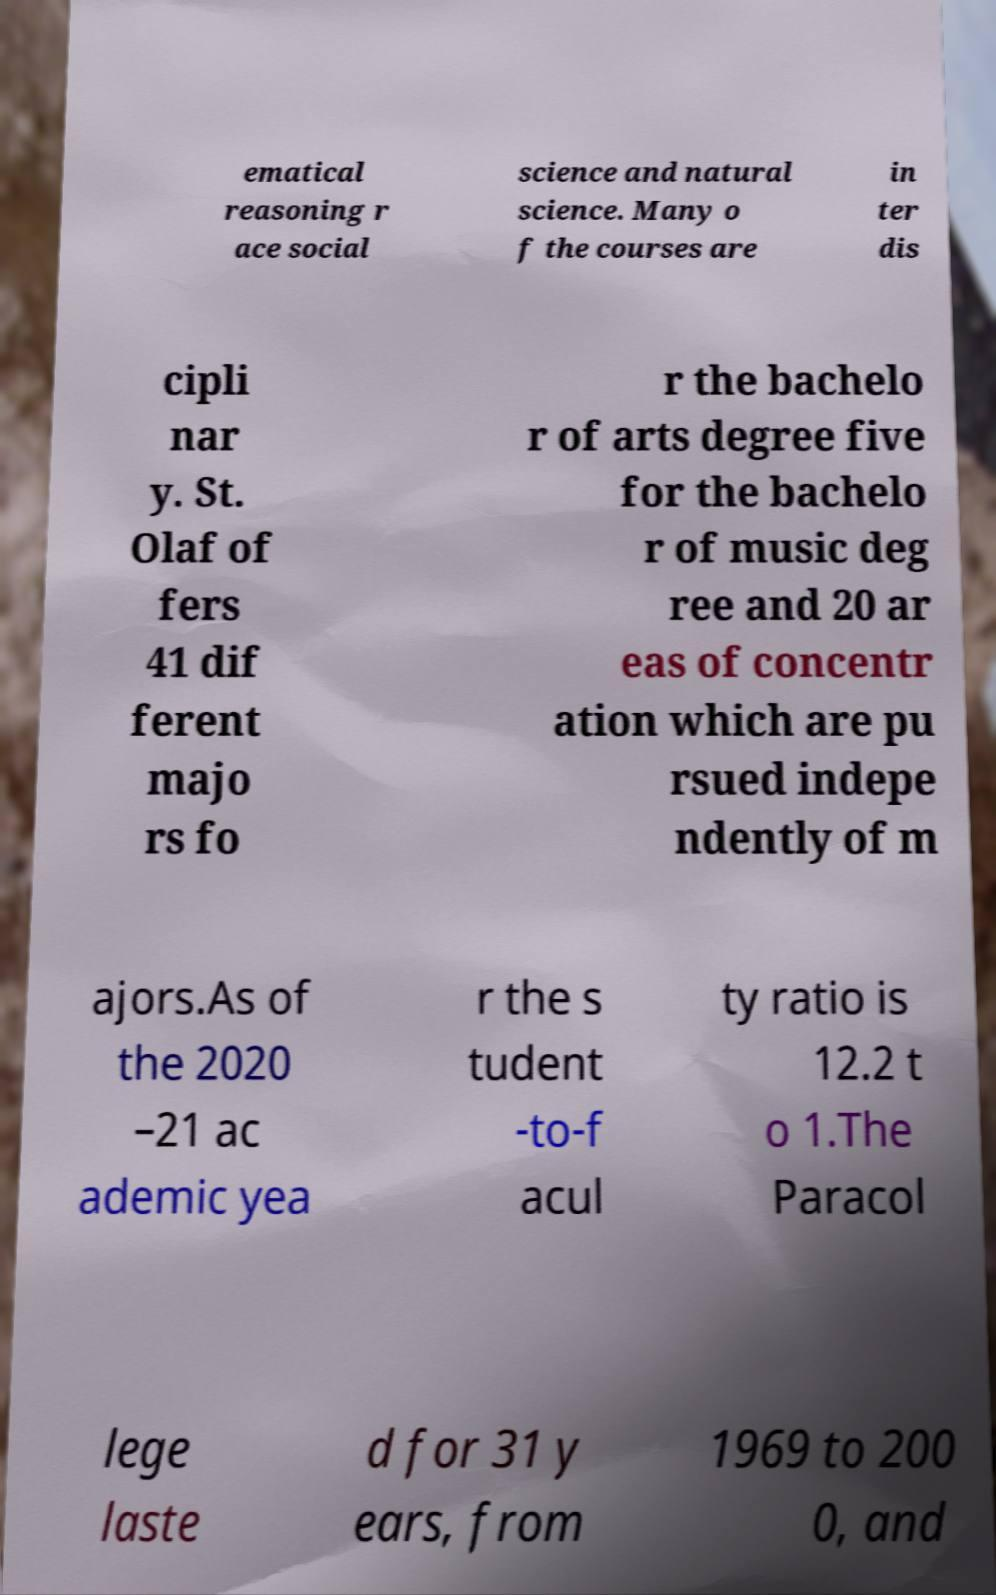Can you accurately transcribe the text from the provided image for me? ematical reasoning r ace social science and natural science. Many o f the courses are in ter dis cipli nar y. St. Olaf of fers 41 dif ferent majo rs fo r the bachelo r of arts degree five for the bachelo r of music deg ree and 20 ar eas of concentr ation which are pu rsued indepe ndently of m ajors.As of the 2020 –21 ac ademic yea r the s tudent -to-f acul ty ratio is 12.2 t o 1.The Paracol lege laste d for 31 y ears, from 1969 to 200 0, and 